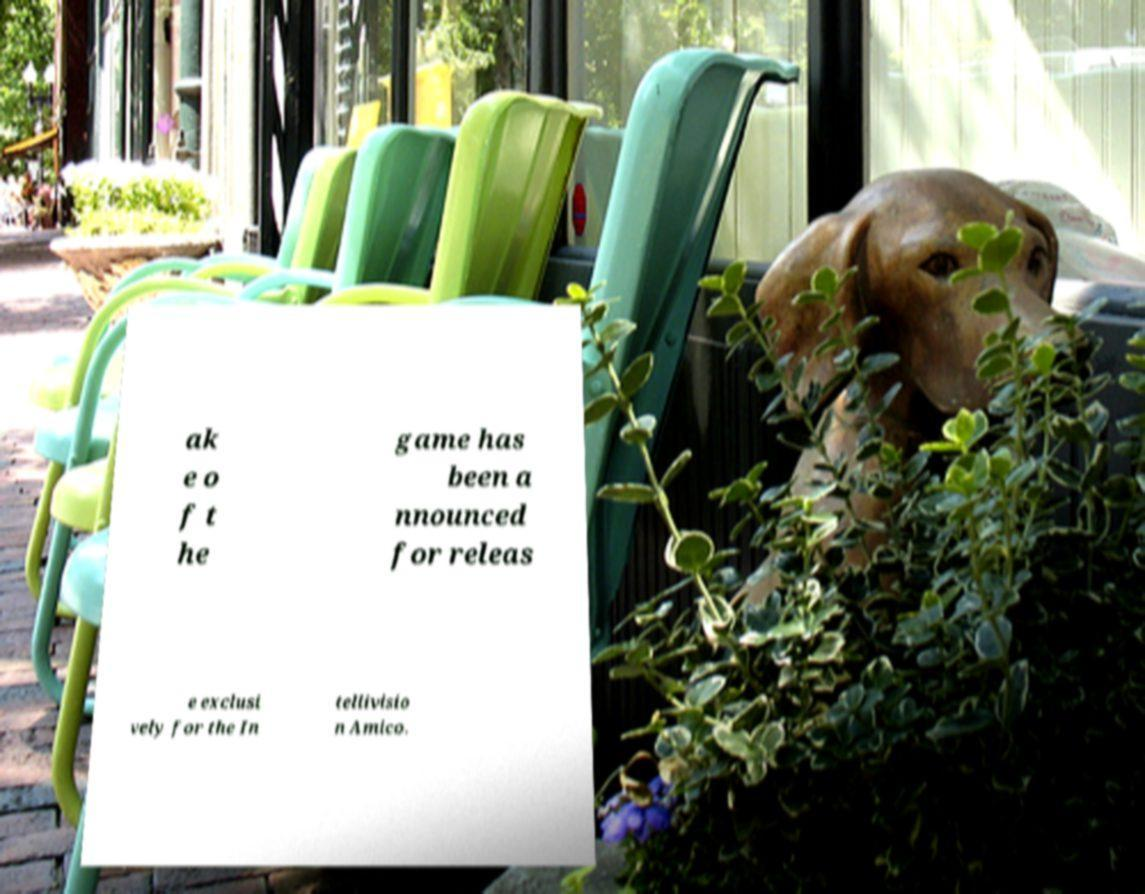Please read and relay the text visible in this image. What does it say? ak e o f t he game has been a nnounced for releas e exclusi vely for the In tellivisio n Amico. 